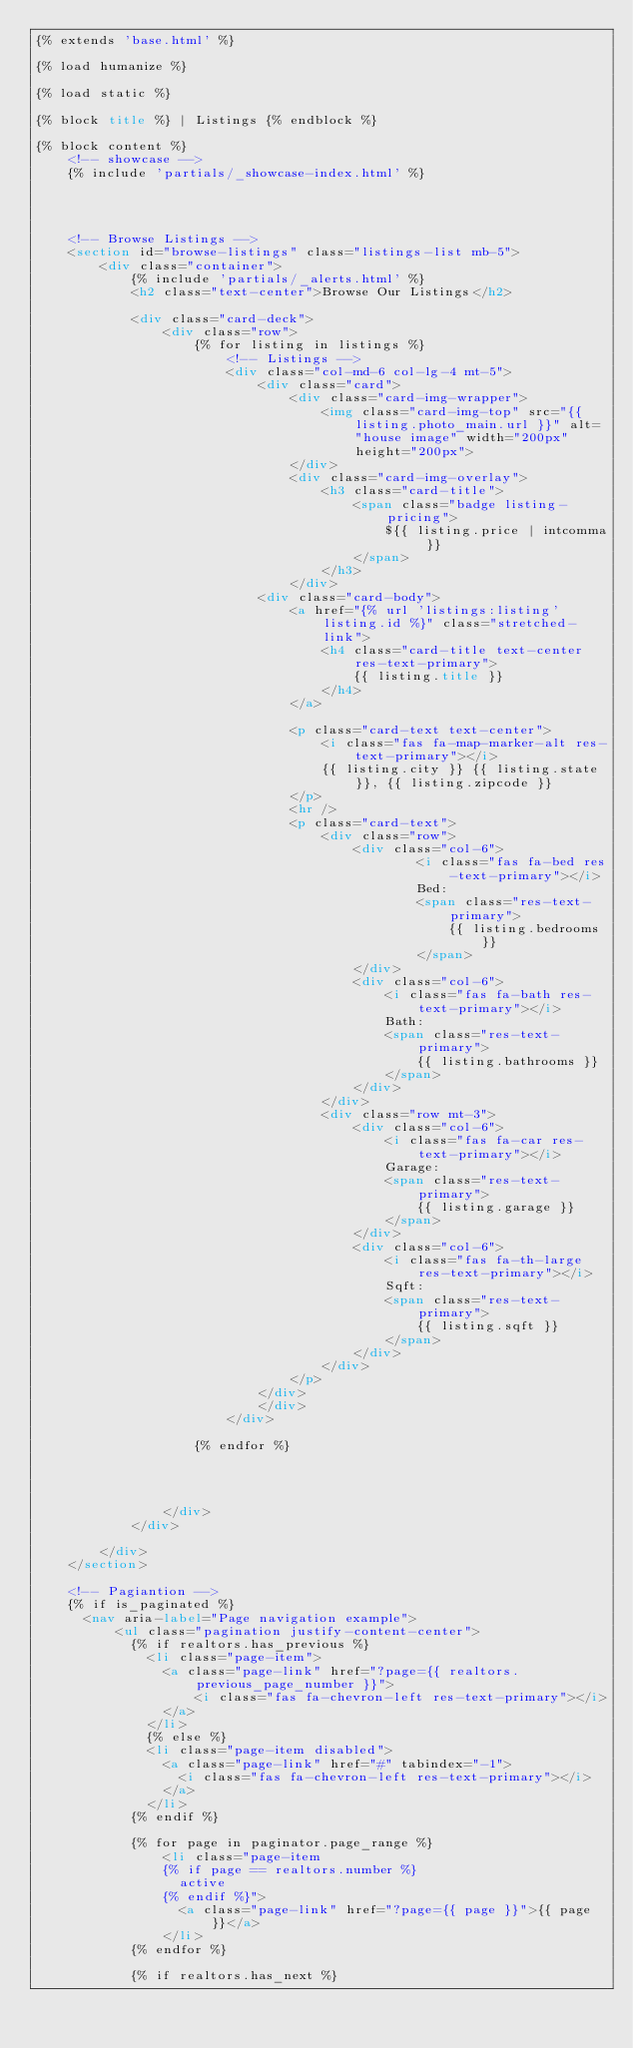<code> <loc_0><loc_0><loc_500><loc_500><_HTML_>{% extends 'base.html' %}

{% load humanize %}

{% load static %}

{% block title %} | Listings {% endblock %}

{% block content %}
    <!-- showcase -->
    {% include 'partials/_showcase-index.html' %}
    


    
    <!-- Browse Listings -->
    <section id="browse-listings" class="listings-list mb-5">
        <div class="container">
            {% include 'partials/_alerts.html' %}
            <h2 class="text-center">Browse Our Listings</h2>

            <div class="card-deck">
                <div class="row">
                    {% for listing in listings %}
                        <!-- Listings -->
                        <div class="col-md-6 col-lg-4 mt-5">
                            <div class="card">
                                <div class="card-img-wrapper">
                                    <img class="card-img-top" src="{{ listing.photo_main.url }}" alt="house image" width="200px" height="200px">
                                </div>
                                <div class="card-img-overlay">
                                    <h3 class="card-title">
                                        <span class="badge listing-pricing">
                                            ${{ listing.price | intcomma }}
                                        </span>
                                    </h3>
                                </div>
                            <div class="card-body">
                                <a href="{% url 'listings:listing' listing.id %}" class="stretched-link">
                                    <h4 class="card-title text-center res-text-primary">
                                        {{ listing.title }}
                                    </h4>
                                </a>
                                
                                <p class="card-text text-center">
                                    <i class="fas fa-map-marker-alt res-text-primary"></i>
                                    {{ listing.city }} {{ listing.state }}, {{ listing.zipcode }}
                                </p>
                                <hr />
                                <p class="card-text">
                                    <div class="row">
                                        <div class="col-6">
                                                <i class="fas fa-bed res-text-primary"></i>
                                                Bed: 
                                                <span class="res-text-primary">
                                                    {{ listing.bedrooms }}
                                                </span>
                                        </div>
                                        <div class="col-6">
                                            <i class="fas fa-bath res-text-primary"></i>
                                            Bath: 
                                            <span class="res-text-primary">
                                                {{ listing.bathrooms }}
                                            </span>
                                        </div>
                                    </div>
                                    <div class="row mt-3">
                                        <div class="col-6">
                                            <i class="fas fa-car res-text-primary"></i>
                                            Garage: 
                                            <span class="res-text-primary">
                                                {{ listing.garage }}
                                            </span>
                                        </div>
                                        <div class="col-6">
                                            <i class="fas fa-th-large res-text-primary"></i>
                                            Sqft: 
                                            <span class="res-text-primary">
                                                {{ listing.sqft }}
                                            </span>
                                        </div>
                                    </div>
                                </p>
                            </div>
                            </div>  
                        </div>

                    {% endfor %}
                    

                   
                    
                </div>
            </div>

        </div>
    </section>

    <!-- Pagiantion -->
    {% if is_paginated %}
      <nav aria-label="Page navigation example">
          <ul class="pagination justify-content-center">
            {% if realtors.has_previous %}
              <li class="page-item">
                <a class="page-link" href="?page={{ realtors.previous_page_number }}">
                    <i class="fas fa-chevron-left res-text-primary"></i>
                </a>
              </li>
              {% else %}
              <li class="page-item disabled">
                <a class="page-link" href="#" tabindex="-1">
                  <i class="fas fa-chevron-left res-text-primary"></i>
                </a>
              </li>
            {% endif %}
            
            {% for page in paginator.page_range %}
                <li class="page-item 
                {% if page == realtors.number %} 
                  active 
                {% endif %}">
                  <a class="page-link" href="?page={{ page }}">{{ page }}</a>
                </li>
            {% endfor %}

            {% if realtors.has_next %}</code> 